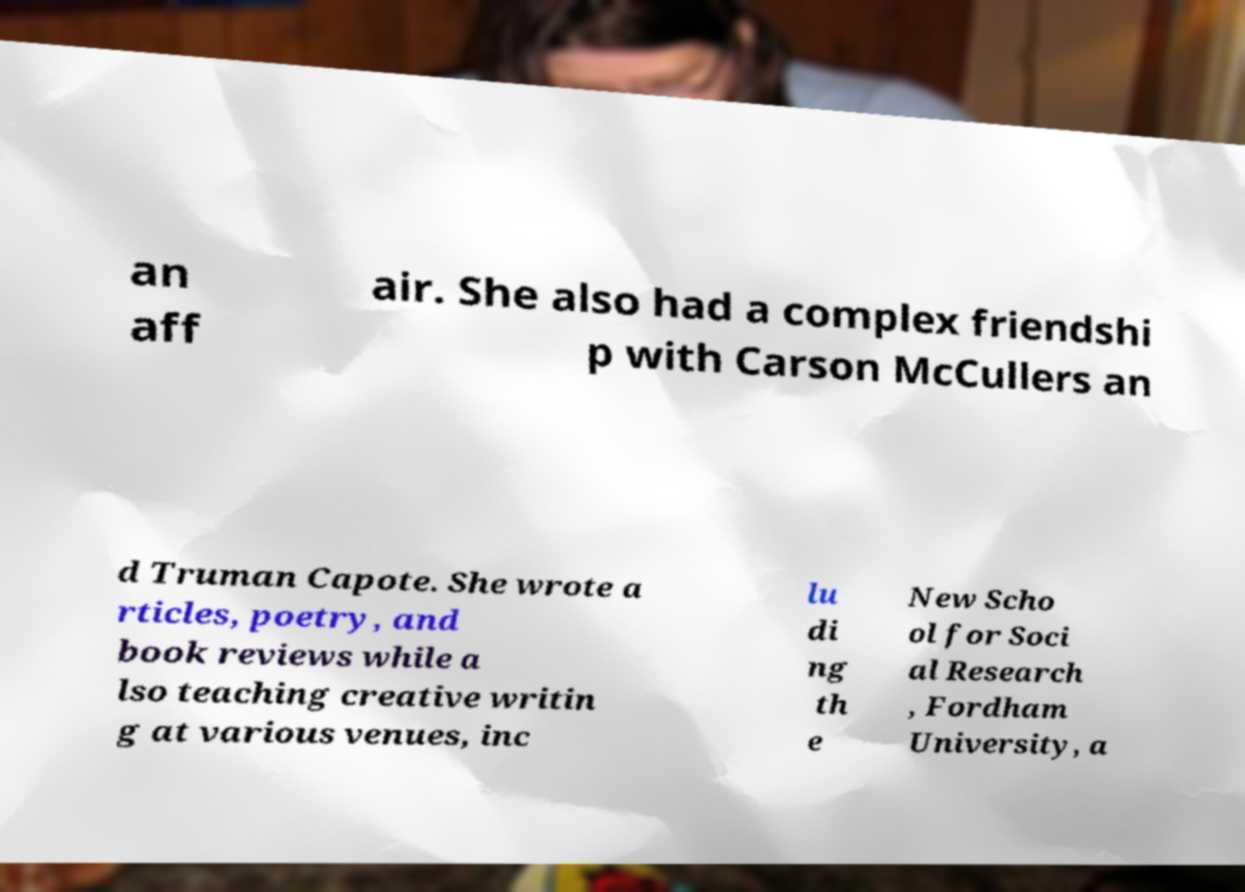Can you accurately transcribe the text from the provided image for me? an aff air. She also had a complex friendshi p with Carson McCullers an d Truman Capote. She wrote a rticles, poetry, and book reviews while a lso teaching creative writin g at various venues, inc lu di ng th e New Scho ol for Soci al Research , Fordham University, a 